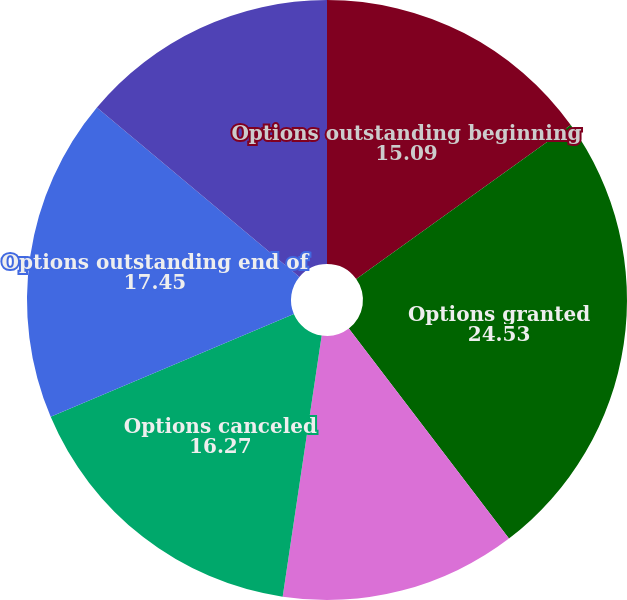Convert chart to OTSL. <chart><loc_0><loc_0><loc_500><loc_500><pie_chart><fcel>Options outstanding beginning<fcel>Options granted<fcel>Options exercised<fcel>Options canceled<fcel>Options outstanding end of<fcel>Options exercisable end of<nl><fcel>15.09%<fcel>24.53%<fcel>12.73%<fcel>16.27%<fcel>17.45%<fcel>13.91%<nl></chart> 